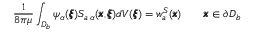Convert formula to latex. <formula><loc_0><loc_0><loc_500><loc_500>\frac { 1 } { 8 \pi \mu } \int _ { D _ { b } } \psi _ { \alpha } ( { \pm b \xi } ) S _ { a \, \alpha } ( { \pm b x } , { \pm b \xi } ) d V ( { \pm b \xi } ) = { w } _ { a } ^ { S } ( { \pm b x } ) \quad { \pm b x } \in \partial D _ { b }</formula> 